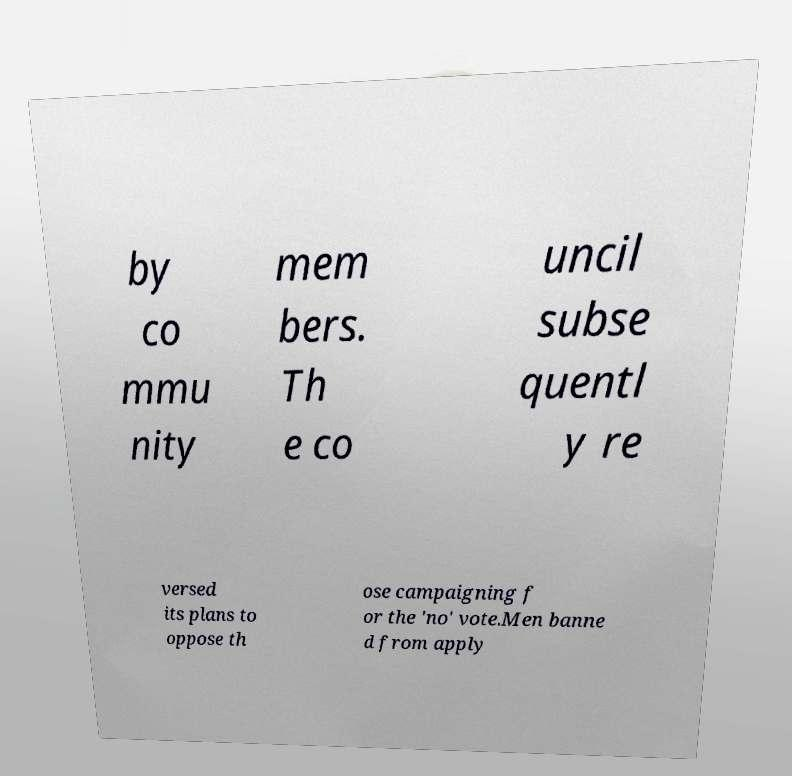Could you assist in decoding the text presented in this image and type it out clearly? by co mmu nity mem bers. Th e co uncil subse quentl y re versed its plans to oppose th ose campaigning f or the 'no' vote.Men banne d from apply 